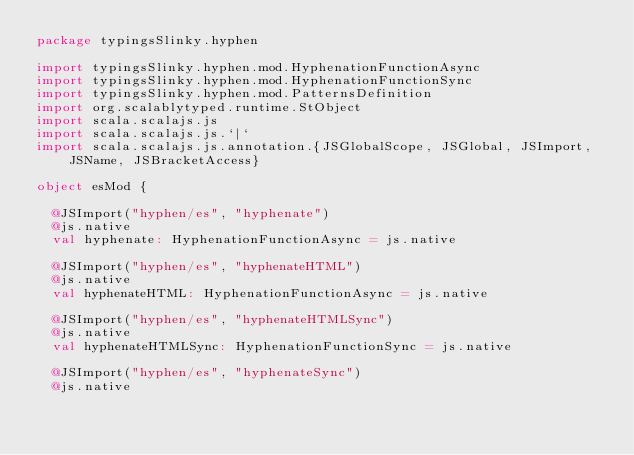Convert code to text. <code><loc_0><loc_0><loc_500><loc_500><_Scala_>package typingsSlinky.hyphen

import typingsSlinky.hyphen.mod.HyphenationFunctionAsync
import typingsSlinky.hyphen.mod.HyphenationFunctionSync
import typingsSlinky.hyphen.mod.PatternsDefinition
import org.scalablytyped.runtime.StObject
import scala.scalajs.js
import scala.scalajs.js.`|`
import scala.scalajs.js.annotation.{JSGlobalScope, JSGlobal, JSImport, JSName, JSBracketAccess}

object esMod {
  
  @JSImport("hyphen/es", "hyphenate")
  @js.native
  val hyphenate: HyphenationFunctionAsync = js.native
  
  @JSImport("hyphen/es", "hyphenateHTML")
  @js.native
  val hyphenateHTML: HyphenationFunctionAsync = js.native
  
  @JSImport("hyphen/es", "hyphenateHTMLSync")
  @js.native
  val hyphenateHTMLSync: HyphenationFunctionSync = js.native
  
  @JSImport("hyphen/es", "hyphenateSync")
  @js.native</code> 